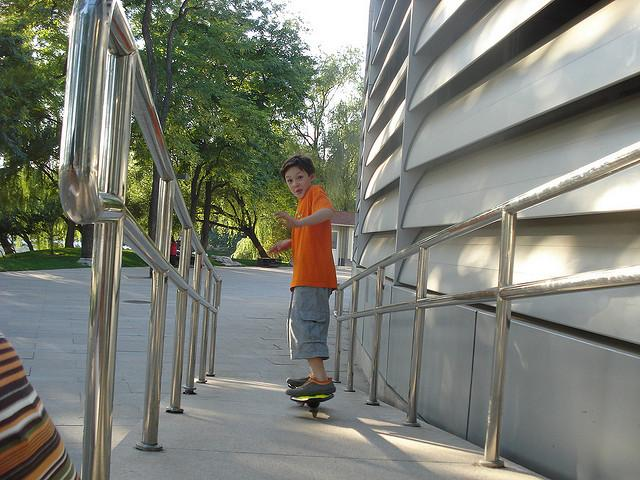What group of people is the ramp here constructed for? handicapped 